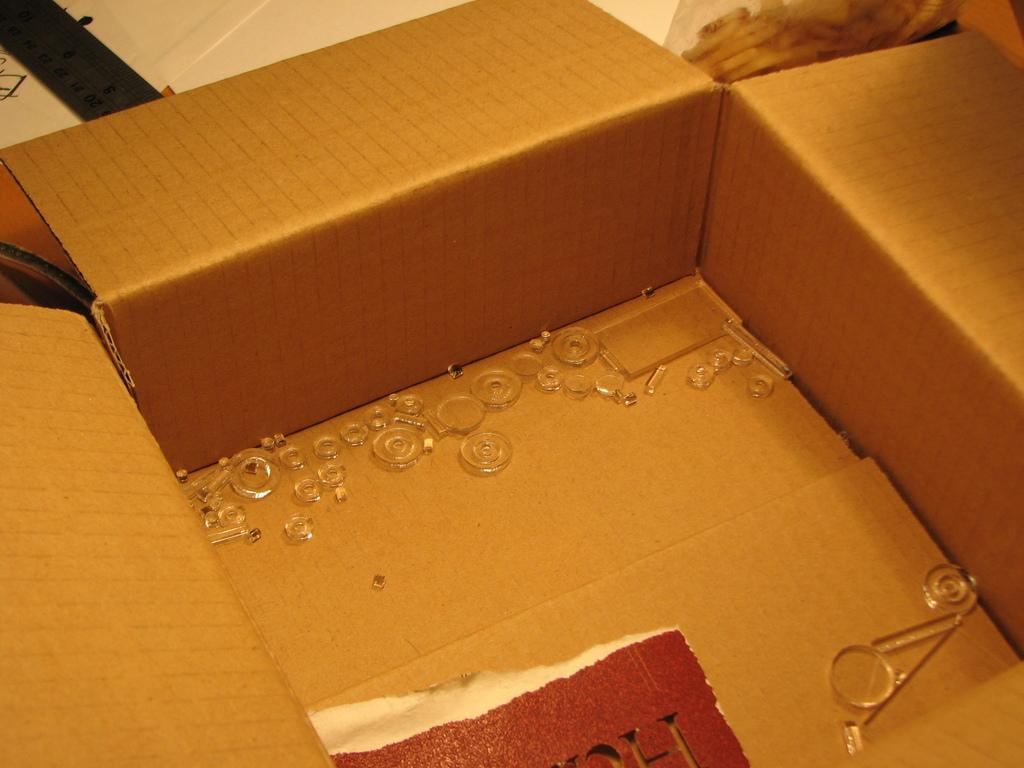What is the main object in the image? There is a box in the image. What is inside the box? There are many objects placed in the box. Where is an object located in the image? There is an object at the right top most of the image. What is located at the left top most of the image? There is a ruler at the left top most of the image. How many copies of the bomb are present in the image? There is no bomb present in the image. 